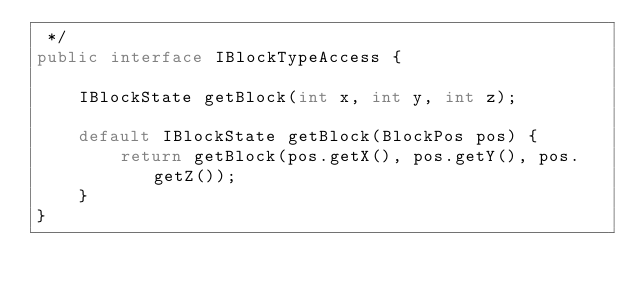Convert code to text. <code><loc_0><loc_0><loc_500><loc_500><_Java_> */
public interface IBlockTypeAccess {

    IBlockState getBlock(int x, int y, int z);

    default IBlockState getBlock(BlockPos pos) {
        return getBlock(pos.getX(), pos.getY(), pos.getZ());
    }
}
</code> 